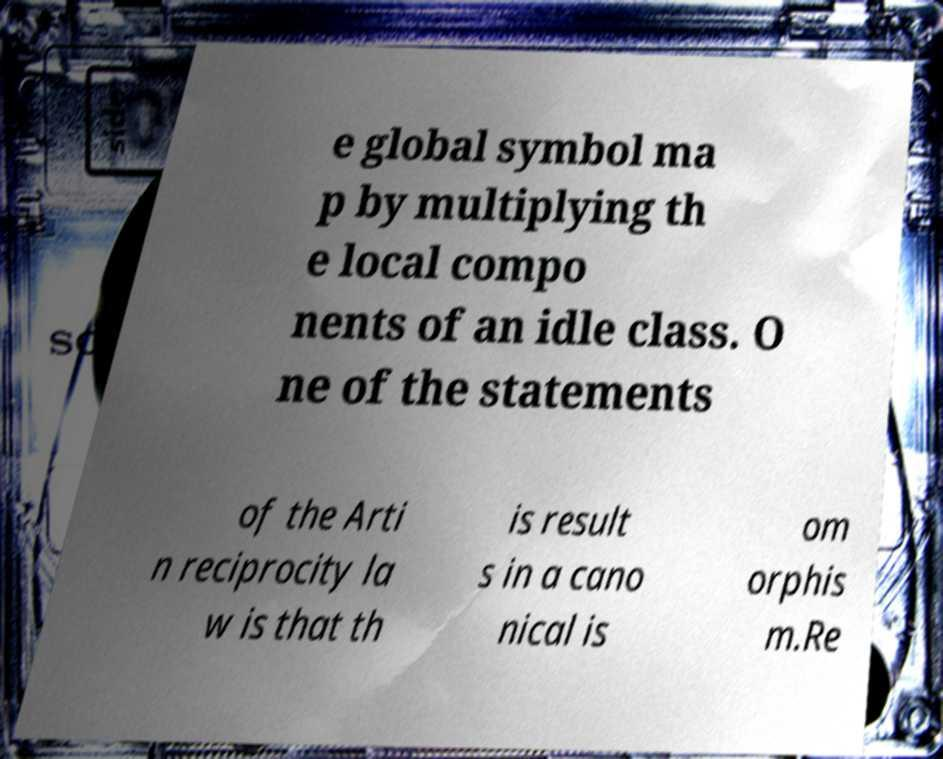I need the written content from this picture converted into text. Can you do that? e global symbol ma p by multiplying th e local compo nents of an idle class. O ne of the statements of the Arti n reciprocity la w is that th is result s in a cano nical is om orphis m.Re 